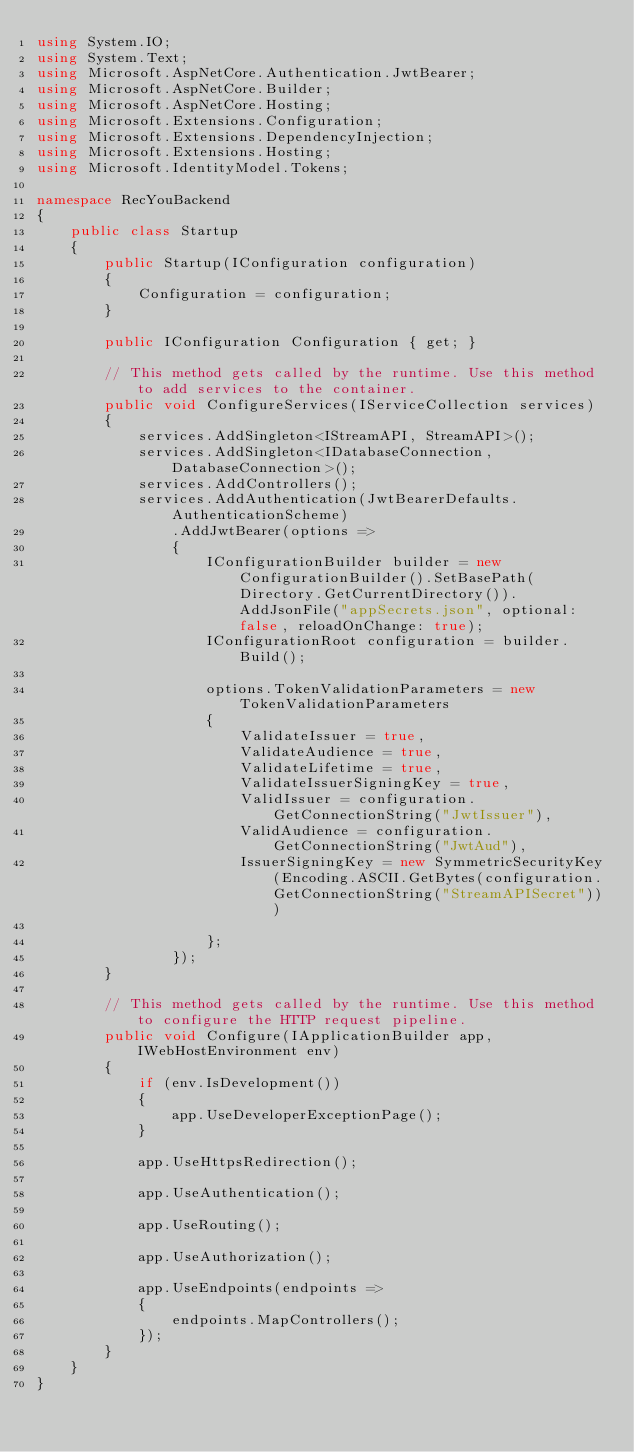Convert code to text. <code><loc_0><loc_0><loc_500><loc_500><_C#_>using System.IO;
using System.Text;
using Microsoft.AspNetCore.Authentication.JwtBearer;
using Microsoft.AspNetCore.Builder;
using Microsoft.AspNetCore.Hosting;
using Microsoft.Extensions.Configuration;
using Microsoft.Extensions.DependencyInjection;
using Microsoft.Extensions.Hosting;
using Microsoft.IdentityModel.Tokens;

namespace RecYouBackend
{
    public class Startup
    {
        public Startup(IConfiguration configuration)
        {
            Configuration = configuration;
        }

        public IConfiguration Configuration { get; }

        // This method gets called by the runtime. Use this method to add services to the container.
        public void ConfigureServices(IServiceCollection services)
        {
            services.AddSingleton<IStreamAPI, StreamAPI>();
            services.AddSingleton<IDatabaseConnection, DatabaseConnection>();
            services.AddControllers();
            services.AddAuthentication(JwtBearerDefaults.AuthenticationScheme)
                .AddJwtBearer(options =>
                {
                    IConfigurationBuilder builder = new ConfigurationBuilder().SetBasePath(Directory.GetCurrentDirectory()).AddJsonFile("appSecrets.json", optional: false, reloadOnChange: true);
                    IConfigurationRoot configuration = builder.Build();

                    options.TokenValidationParameters = new TokenValidationParameters
                    {
                        ValidateIssuer = true,
                        ValidateAudience = true,
                        ValidateLifetime = true,
                        ValidateIssuerSigningKey = true,
                        ValidIssuer = configuration.GetConnectionString("JwtIssuer"),
                        ValidAudience = configuration.GetConnectionString("JwtAud"),
                        IssuerSigningKey = new SymmetricSecurityKey(Encoding.ASCII.GetBytes(configuration.GetConnectionString("StreamAPISecret")))
                
                    };
                });
        }

        // This method gets called by the runtime. Use this method to configure the HTTP request pipeline.
        public void Configure(IApplicationBuilder app, IWebHostEnvironment env)
        {
            if (env.IsDevelopment())
            {
                app.UseDeveloperExceptionPage();
            }

            app.UseHttpsRedirection();

            app.UseAuthentication();

            app.UseRouting();

            app.UseAuthorization();

            app.UseEndpoints(endpoints =>
            {
                endpoints.MapControllers();
            });
        }
    }
}
</code> 